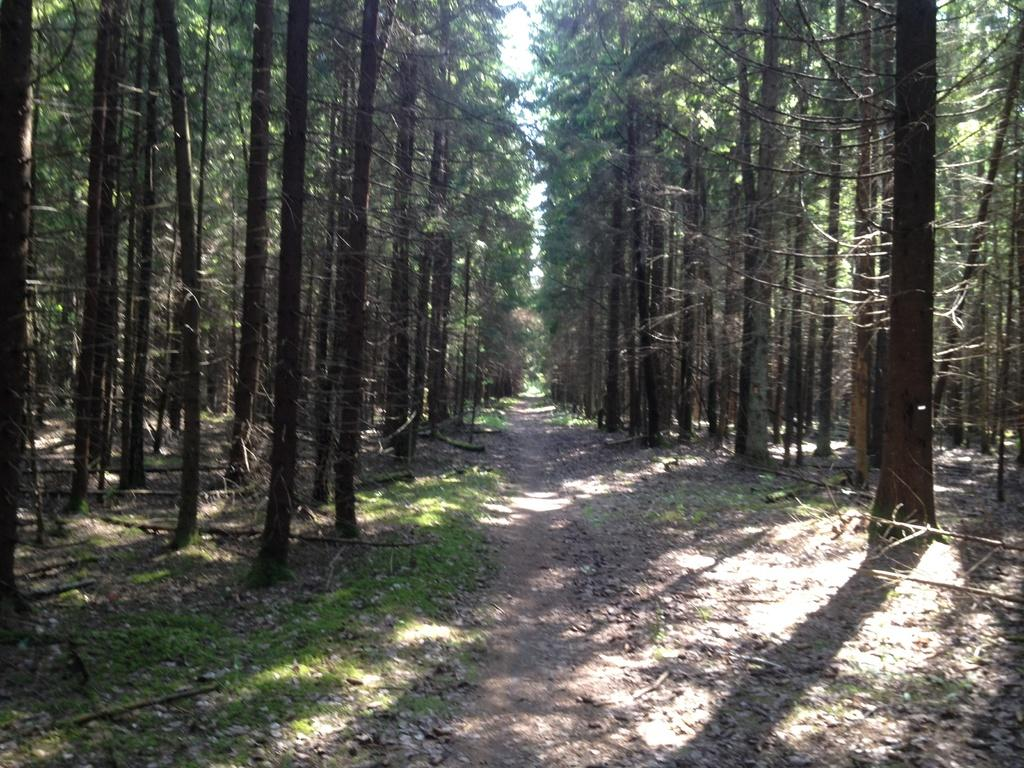What type of vegetation can be seen in the image? There are trees in the image. What is present at the bottom of the image? There is sand and grass at the bottom of the image. What is visible at the top of the image? The sky is visible at the top of the image. What type of bubble is floating in the sky in the image? There is no bubble present in the image; only trees, sand, grass, and the sky are visible. What title can be seen on the trees in the image? There is no title present on the trees in the image; they are simply depicted as trees. 